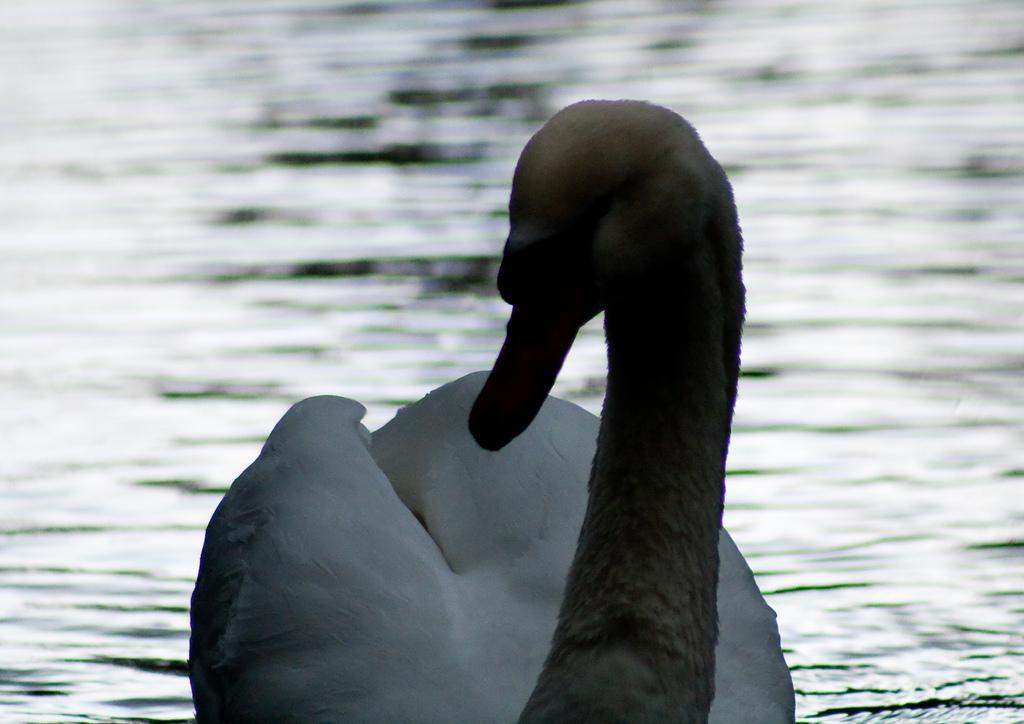Can you describe this image briefly? In this image, we can see a bird and some water. 